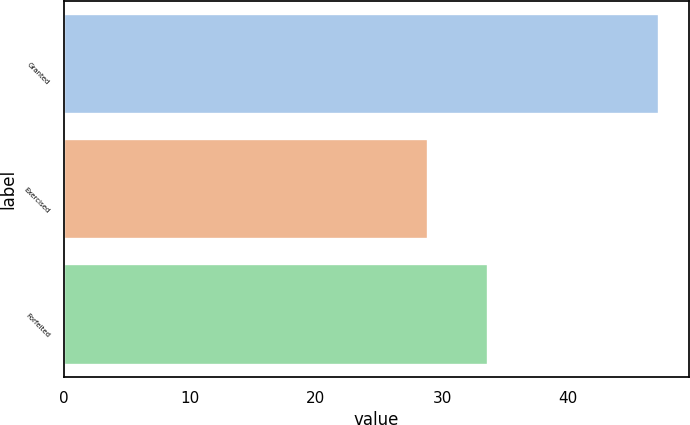Convert chart. <chart><loc_0><loc_0><loc_500><loc_500><bar_chart><fcel>Granted<fcel>Exercised<fcel>Forfeited<nl><fcel>47.22<fcel>28.89<fcel>33.6<nl></chart> 